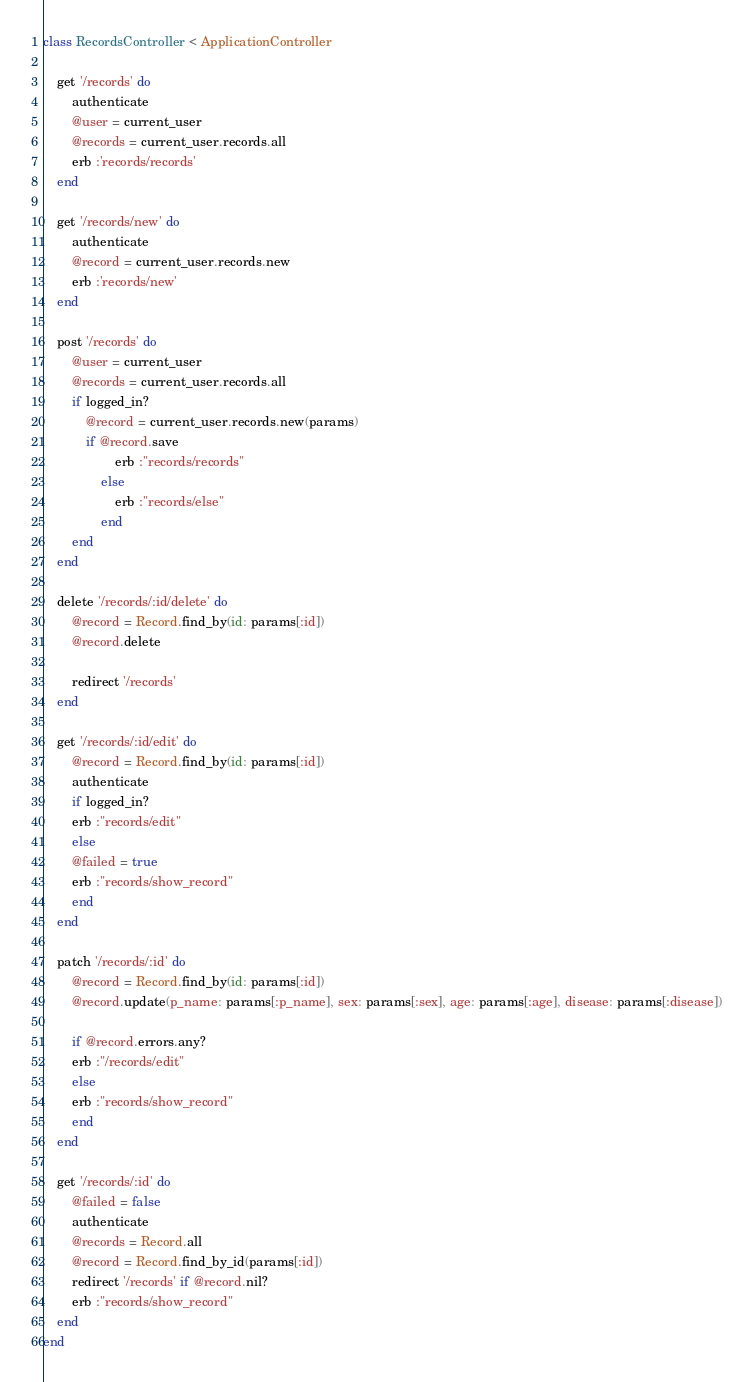<code> <loc_0><loc_0><loc_500><loc_500><_Ruby_>class RecordsController < ApplicationController

    get '/records' do
        authenticate
        @user = current_user
        @records = current_user.records.all
        erb :'records/records'
    end

    get '/records/new' do 
        authenticate
        @record = current_user.records.new
        erb :'records/new'
    end

    post '/records' do
        @user = current_user
        @records = current_user.records.all
        if logged_in?
            @record = current_user.records.new(params)
            if @record.save 
                    erb :"records/records"
                else 
                    erb :"records/else"
                end
        end
    end

    delete '/records/:id/delete' do 
        @record = Record.find_by(id: params[:id])
        @record.delete
 
        redirect '/records'
    end

    get '/records/:id/edit' do
        @record = Record.find_by(id: params[:id])
        authenticate
        if logged_in? 
        erb :"records/edit"
        else
        @failed = true
        erb :"records/show_record"
        end
    end

    patch '/records/:id' do
        @record = Record.find_by(id: params[:id])
        @record.update(p_name: params[:p_name], sex: params[:sex], age: params[:age], disease: params[:disease])
                
        if @record.errors.any?
        erb :"/records/edit"
        else
        erb :"records/show_record"
        end
    end

    get '/records/:id' do  
        @failed = false
        authenticate
        @records = Record.all
        @record = Record.find_by_id(params[:id])
        redirect '/records' if @record.nil?
        erb :"records/show_record"
    end
end</code> 